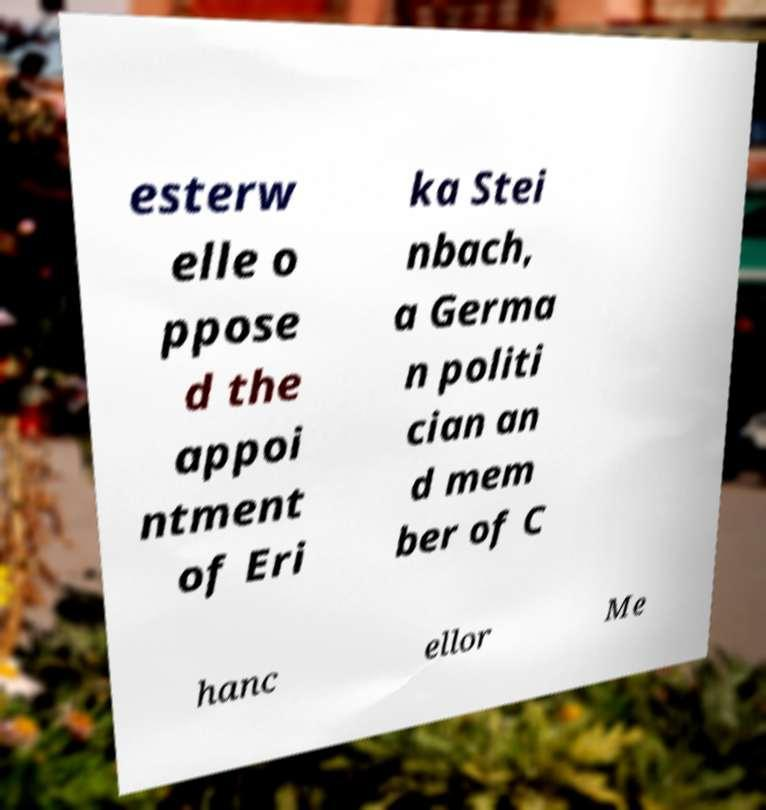Could you assist in decoding the text presented in this image and type it out clearly? esterw elle o ppose d the appoi ntment of Eri ka Stei nbach, a Germa n politi cian an d mem ber of C hanc ellor Me 